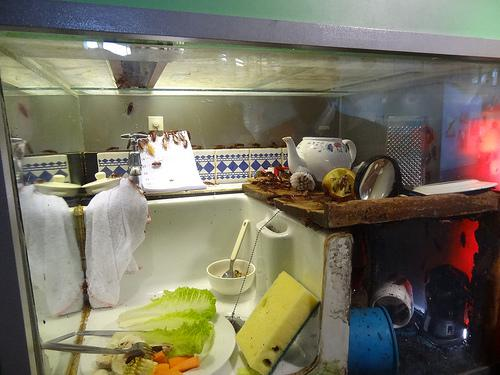Question: what color is the ceiling?
Choices:
A. Blue.
B. White.
C. Green.
D. Red.
Answer with the letter. Answer: B 